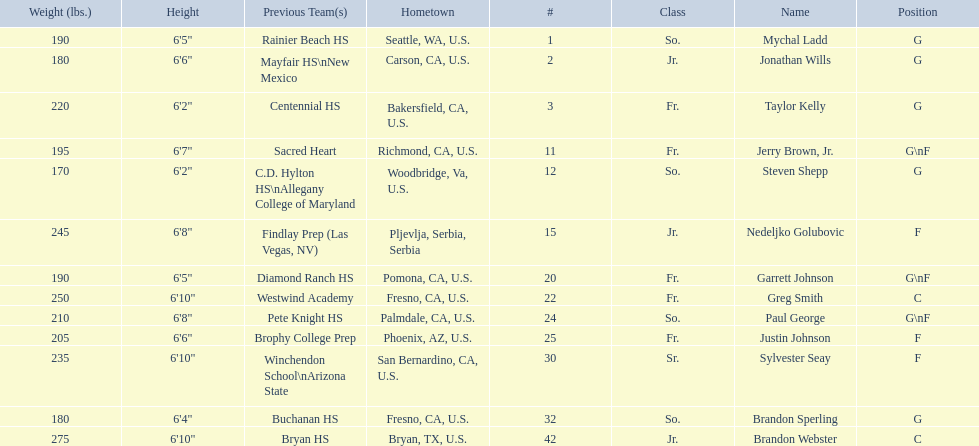Who played during the 2009-10 fresno state bulldogs men's basketball team? Mychal Ladd, Jonathan Wills, Taylor Kelly, Jerry Brown, Jr., Steven Shepp, Nedeljko Golubovic, Garrett Johnson, Greg Smith, Paul George, Justin Johnson, Sylvester Seay, Brandon Sperling, Brandon Webster. What was the position of each player? G, G, G, G\nF, G, F, G\nF, C, G\nF, F, F, G, C. And how tall were they? 6'5", 6'6", 6'2", 6'7", 6'2", 6'8", 6'5", 6'10", 6'8", 6'6", 6'10", 6'4", 6'10". Of these players, who was the shortest forward player? Justin Johnson. 